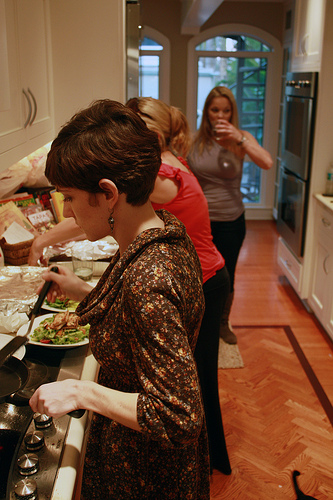Please provide a short description for this region: [0.55, 0.07, 0.71, 0.11]. A small window. This small window allows natural light to enter the room. 